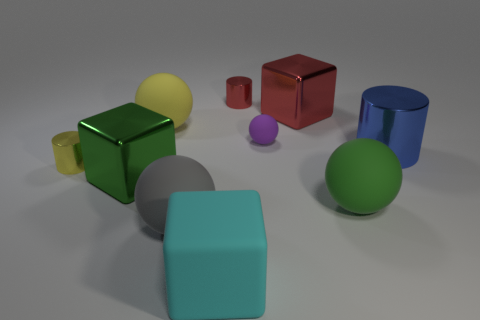Subtract 1 balls. How many balls are left? 3 Subtract all cylinders. How many objects are left? 7 Subtract 1 yellow cylinders. How many objects are left? 9 Subtract all large brown cubes. Subtract all large spheres. How many objects are left? 7 Add 8 small red metallic objects. How many small red metallic objects are left? 9 Add 6 purple rubber balls. How many purple rubber balls exist? 7 